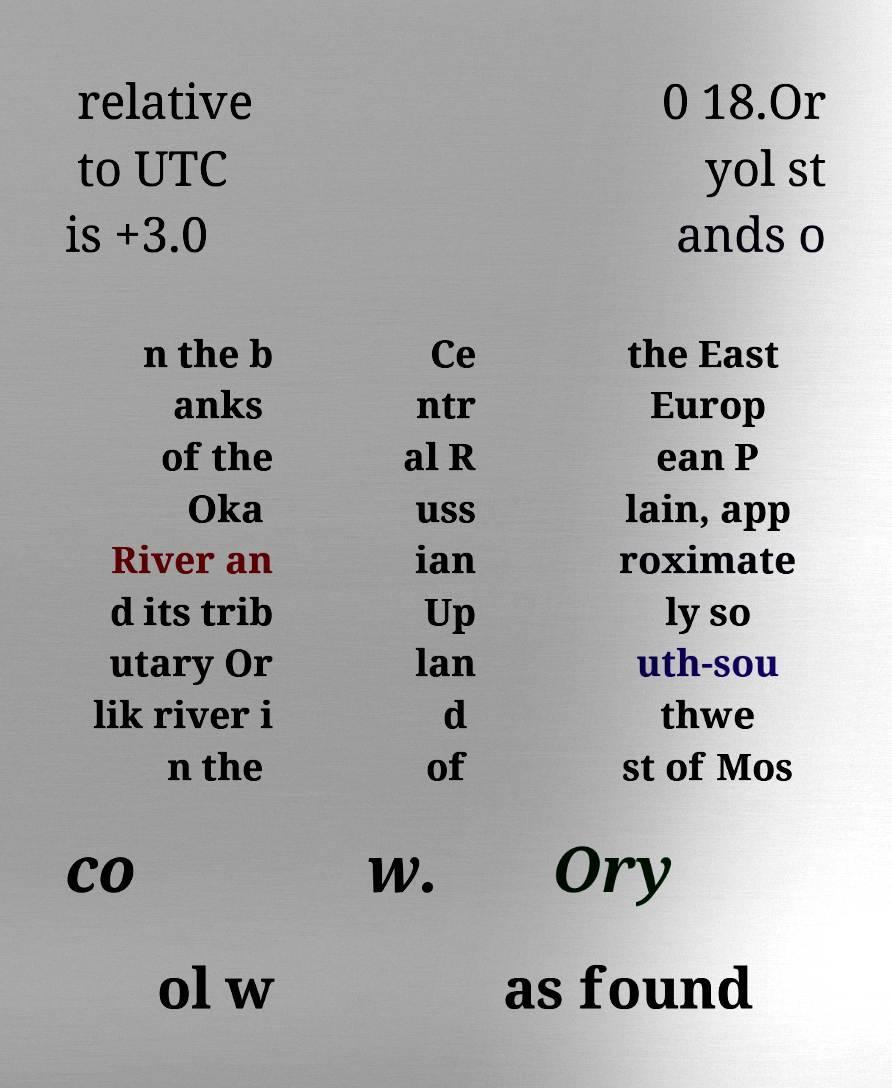For documentation purposes, I need the text within this image transcribed. Could you provide that? relative to UTC is +3.0 0 18.Or yol st ands o n the b anks of the Oka River an d its trib utary Or lik river i n the Ce ntr al R uss ian Up lan d of the East Europ ean P lain, app roximate ly so uth-sou thwe st of Mos co w. Ory ol w as found 